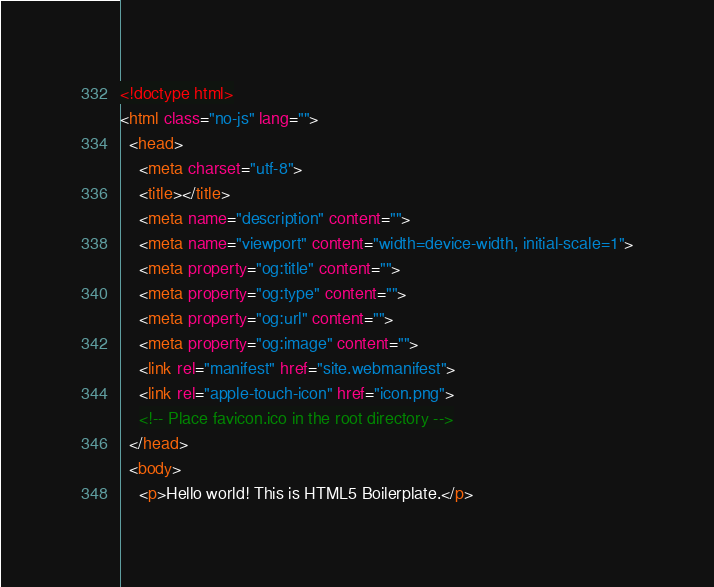Convert code to text. <code><loc_0><loc_0><loc_500><loc_500><_HTML_><!doctype html>
<html class="no-js" lang="">
  <head>
    <meta charset="utf-8">
    <title></title>
    <meta name="description" content="">
    <meta name="viewport" content="width=device-width, initial-scale=1">
    <meta property="og:title" content="">
    <meta property="og:type" content="">
    <meta property="og:url" content="">
    <meta property="og:image" content="">
    <link rel="manifest" href="site.webmanifest">
    <link rel="apple-touch-icon" href="icon.png">
    <!-- Place favicon.ico in the root directory -->
  </head>
  <body>
    <p>Hello world! This is HTML5 Boilerplate.</p></code> 